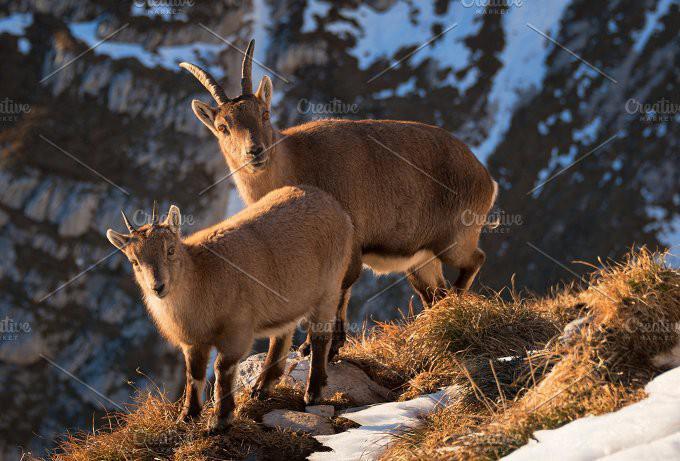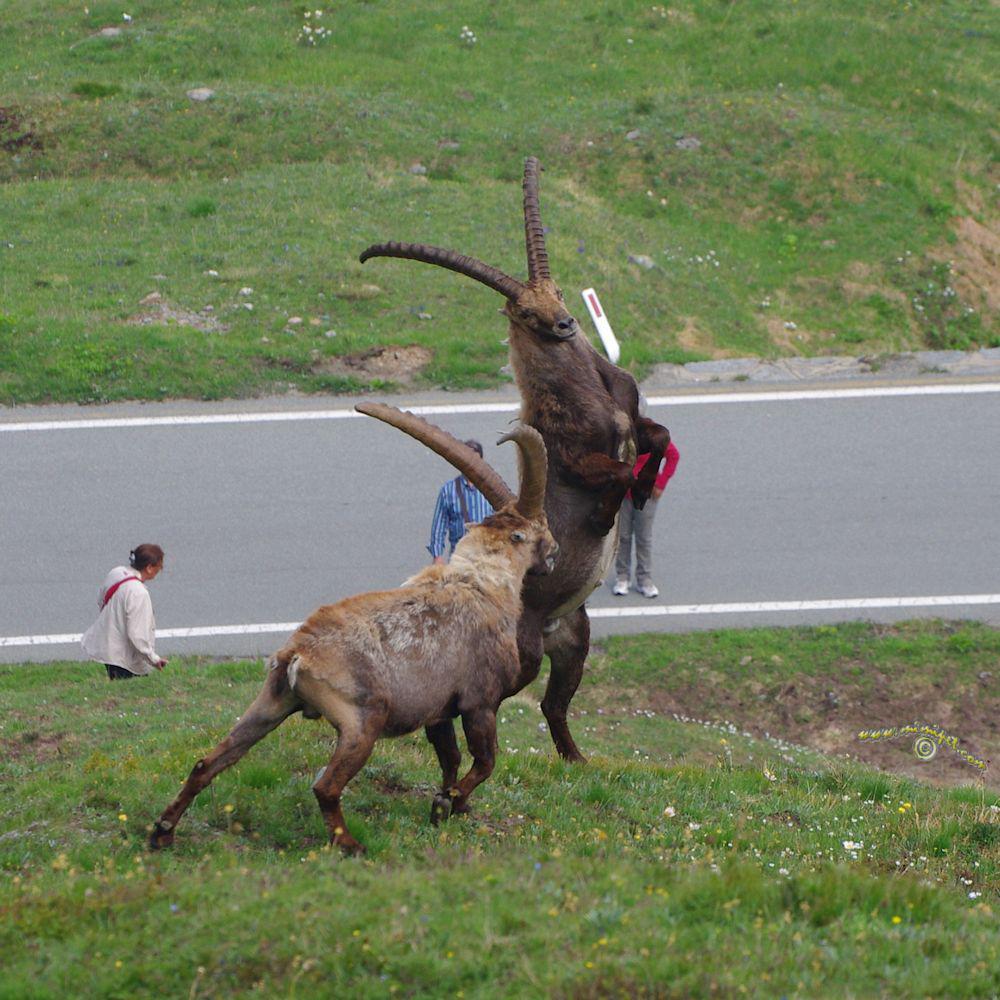The first image is the image on the left, the second image is the image on the right. Given the left and right images, does the statement "The left image shows two goats that are touching each other." hold true? Answer yes or no. Yes. 